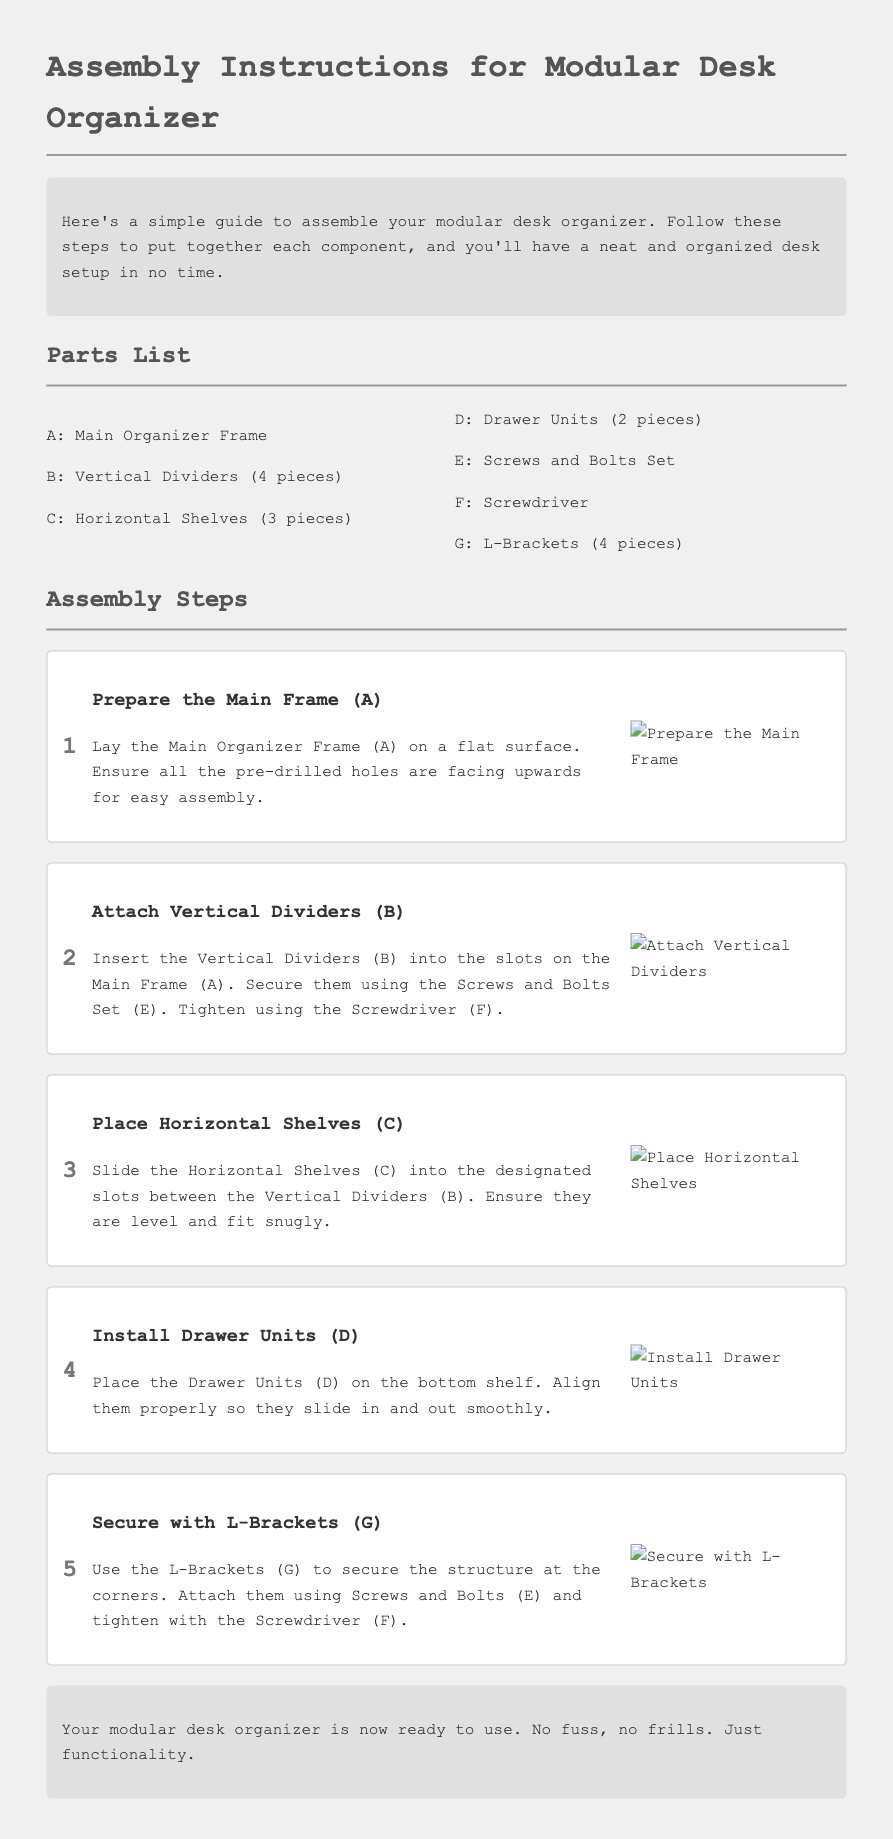What is part A? Part A of the desk organizer is the Main Organizer Frame, as listed in the Parts List.
Answer: Main Organizer Frame How many Vertical Dividers are there? The document mentions there are 4 Vertical Dividers in the Parts List.
Answer: 4 What is used to secure the Drawer Units? The Drawer Units are secured by placing them on the bottom shelf, as stated in the assembly steps.
Answer: Bottom shelf How many steps are there in total? The document describes 5 steps in the Assembly Steps section.
Answer: 5 What tool is required to tighten the screws? The assembly instructions specify that a Screwdriver is required to tighten the screws.
Answer: Screwdriver Which part is aligned for smooth sliding? The document states that the Drawer Units should be aligned properly so they slide in and out smoothly.
Answer: Drawer Units What should be ensured when placing Horizontal Shelves? It is stated that the Horizontal Shelves should be level and fit snugly in their designated slots.
Answer: Level and snug What is the final statement about the organizer? The final statement describes that the modular desk organizer is now ready to use, indicating no fuss and just functionality.
Answer: Ready to use 